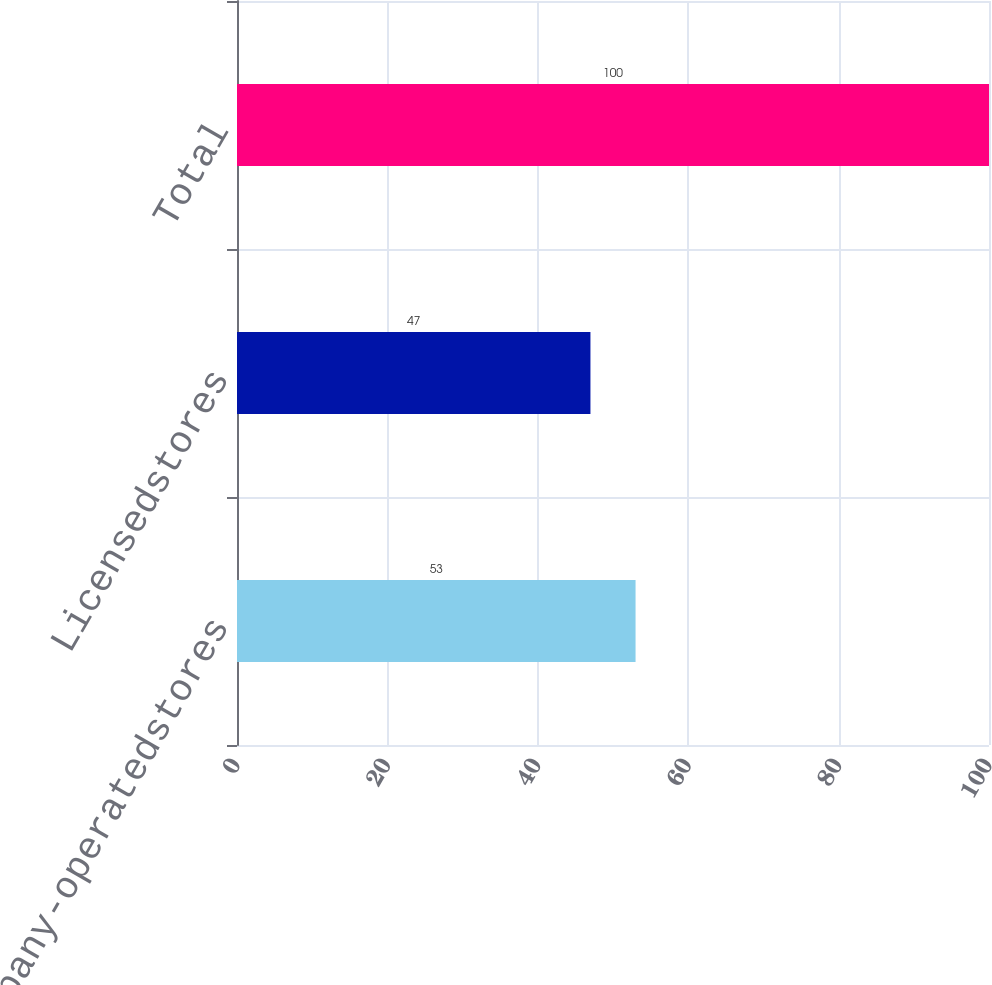Convert chart. <chart><loc_0><loc_0><loc_500><loc_500><bar_chart><fcel>Company-operatedstores<fcel>Licensedstores<fcel>Total<nl><fcel>53<fcel>47<fcel>100<nl></chart> 